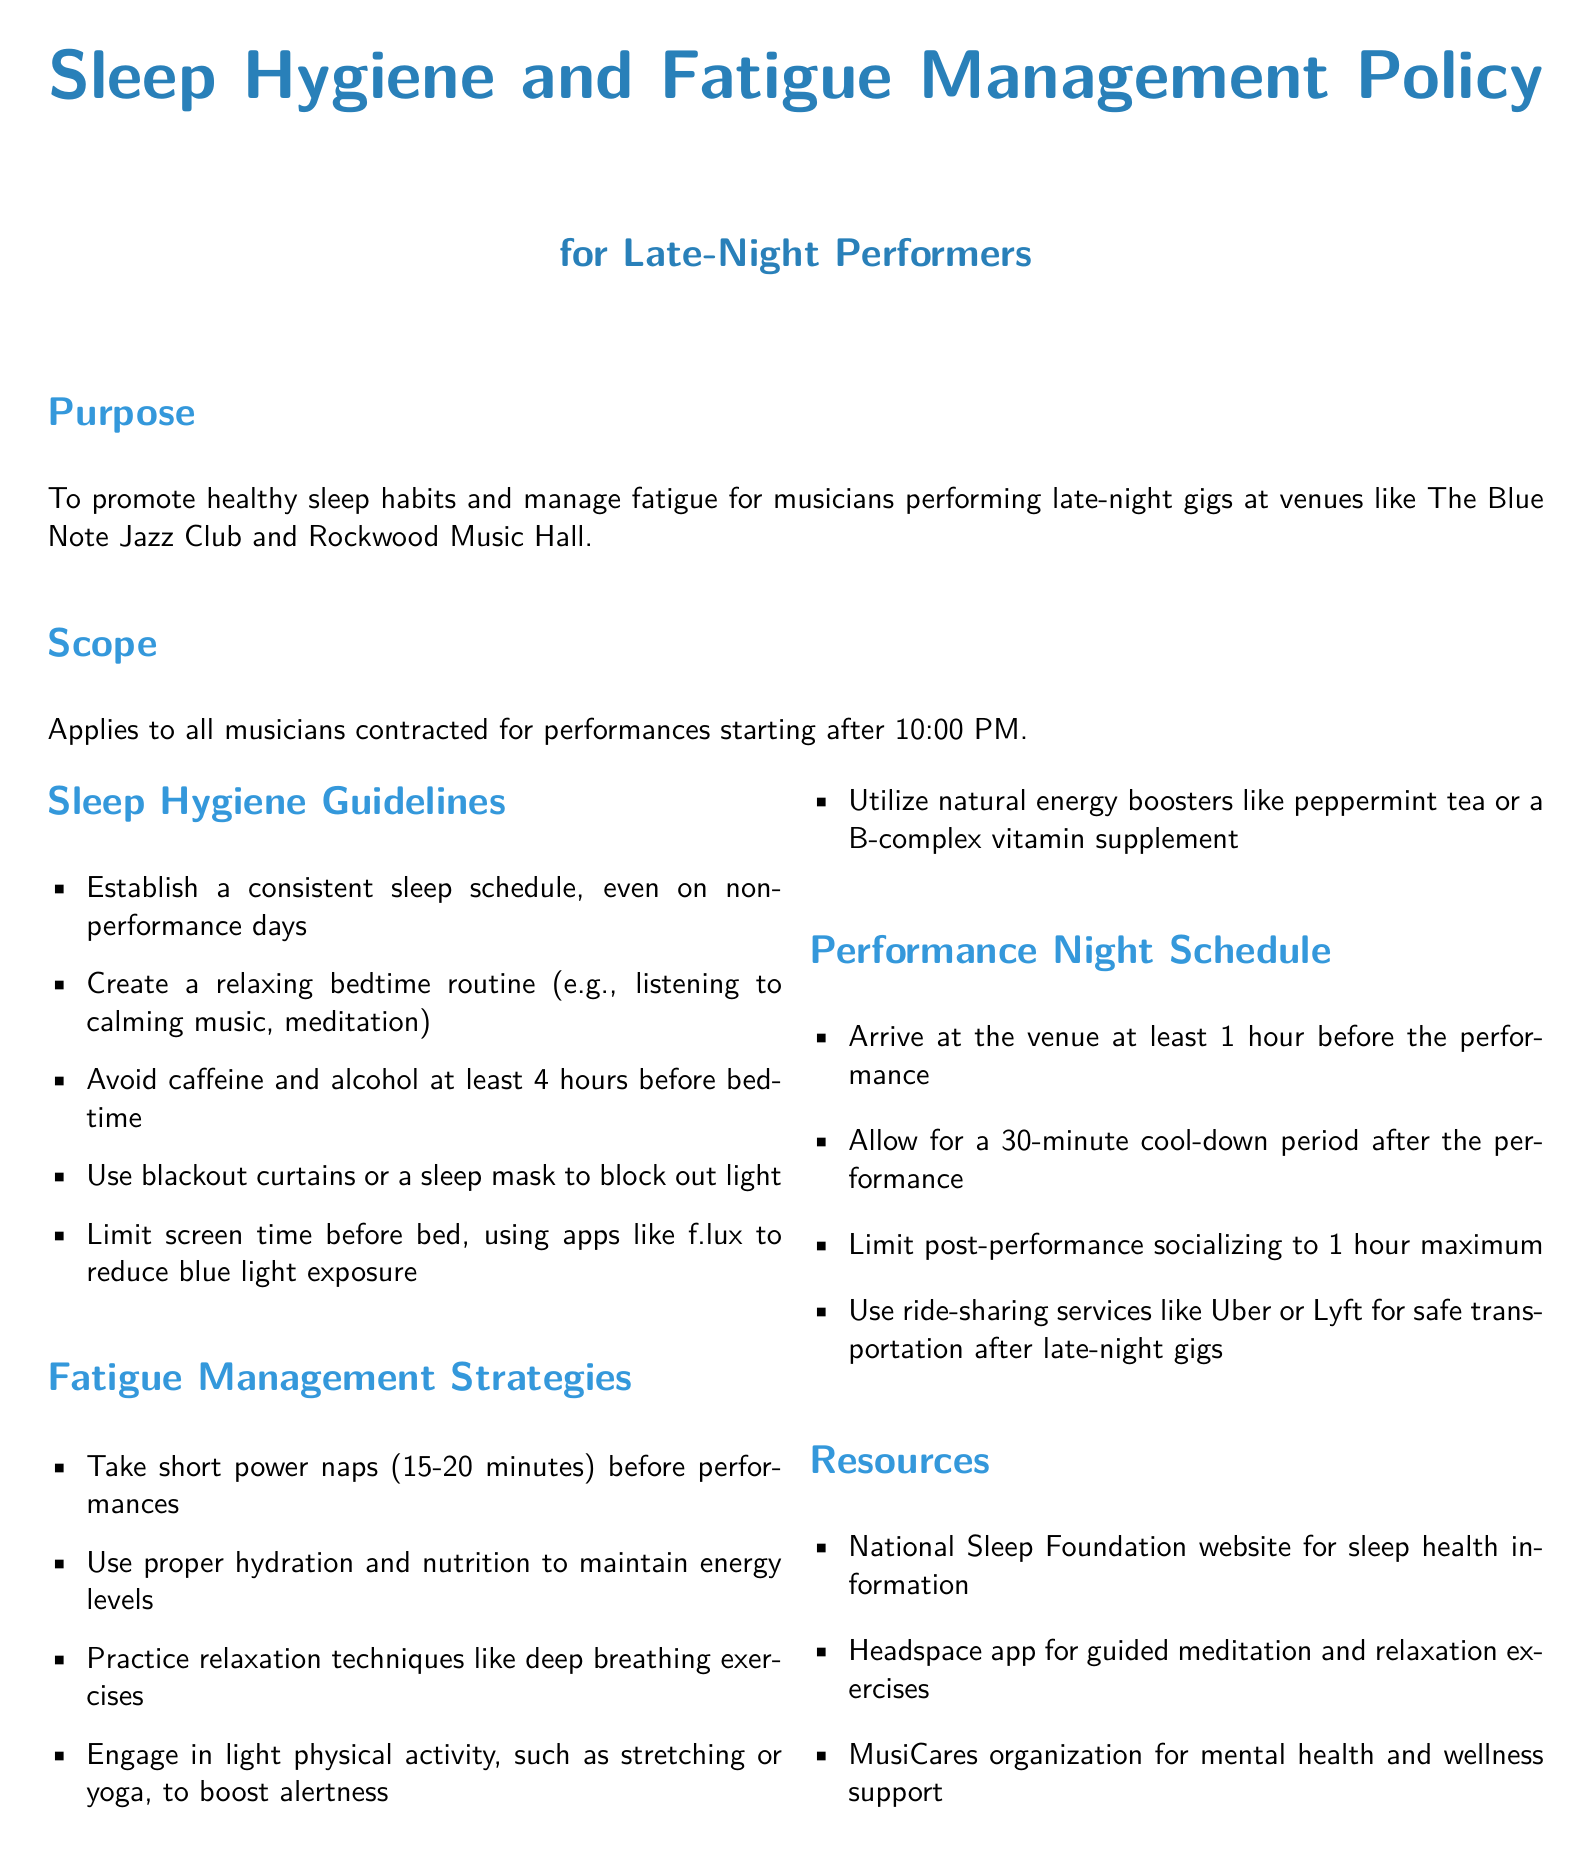What is the purpose of the policy? The purpose is to promote healthy sleep habits and manage fatigue for musicians performing late-night gigs.
Answer: Promote healthy sleep habits and manage fatigue Who does the policy apply to? The policy applies to all musicians hired for performances beginning after 10:00 PM.
Answer: Musicians contracted for performances starting after 10:00 PM What should be avoided at least 4 hours before bedtime? The document suggests avoiding caffeine and alcohol before sleeping to promote better rest.
Answer: Caffeine and alcohol How long should power naps be before performances? The document specifies that power naps should last for 15-20 minutes before performances.
Answer: 15-20 minutes What should you use to block out light? The guidelines recommend using blackout curtains or a sleep mask to create an ideal sleeping environment.
Answer: Blackout curtains or a sleep mask What is the maximum time allowed for post-performance socializing? The policy suggests limiting post-performance socializing to a maximum of 1 hour.
Answer: 1 hour What resource is mentioned for guided meditation? The document lists the Headspace app as a resource for guided meditation and relaxation exercises.
Answer: Headspace app What is recommended to maintain energy levels? Proper hydration and nutrition are recommended strategies to maintain musicians' energy before and after performances.
Answer: Hydration and nutrition How long should a cool-down period be after a performance? The document states that a cool-down period of 30 minutes is advised after performing.
Answer: 30 minutes 